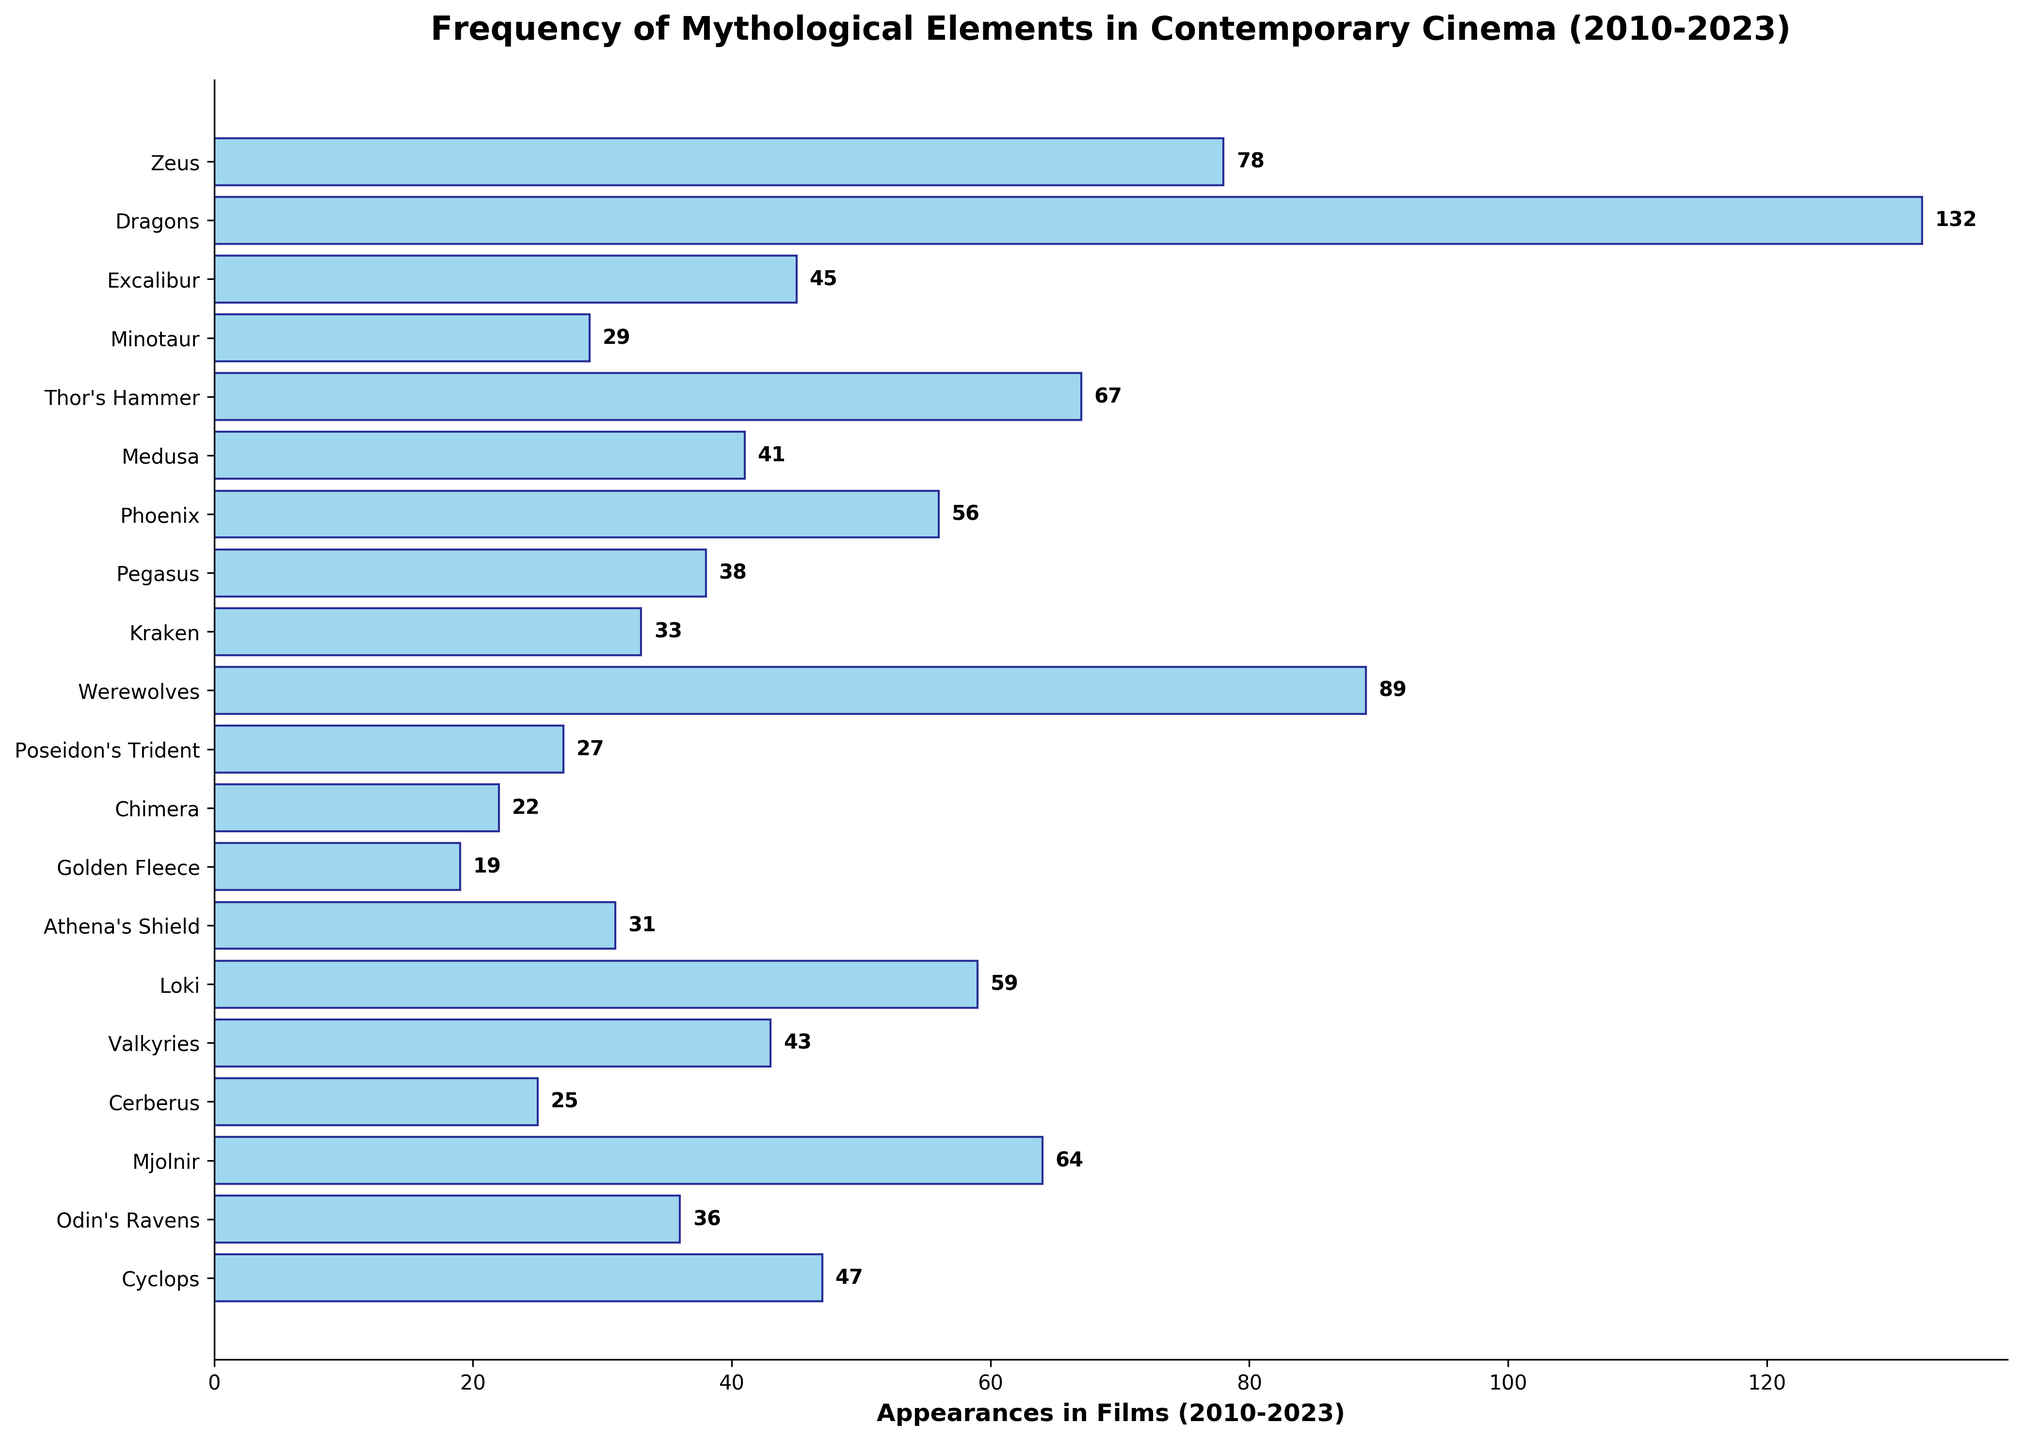What mythological element appears the most frequently in films from 2010 to 2023? To find the most frequent element, look at the bar with the greatest length on the chart. The longest bar represents Dragons with 132 appearances.
Answer: Dragons What is the total number of appearances for Pegasus, Phoenix, and Odin's Ravens together? Sum the appearances of Pegasus (38), Phoenix (56), and Odin's Ravens (36). The total is 38 + 56 + 36 = 130.
Answer: 130 Which mythological element has more appearances: Zeus or Thor's Hammer? Compare the lengths of the bars for Zeus and Thor's Hammer. Zeus has 78 appearances, while Thor's Hammer has 67.
Answer: Zeus What is the difference in appearances between Mjolnir and Loki? Subtract the appearance count of Loki (59) from Mjolnir (64). The difference is 64 - 59 = 5.
Answer: 5 How many mythological elements have appearances less than 30? Count the bars with values less than 30. These are Minotaur (29), Poseidon's Trident (27), Chimera (22), Golden Fleece (19), and Cerberus (25). There are 5 such elements.
Answer: 5 What is the mean number of appearances for the three most frequent mythological elements? The top three elements are Dragons (132), Werewolves (89), and Zeus (78). Sum their appearances and divide by 3. (132 + 89 + 78) / 3 = 299 / 3 = 99.67.
Answer: 99.67 Which element has fewer appearances: Medusa or Cyclops? Compare the lengths of Medusa and Cyclops. Medusa has 41 appearances, while Cyclops has 47.
Answer: Medusa How many elements have appearances between 40 and 60 inclusive? Count the bars where the appearance number is between 40 and 60, including both limits. These elements are Medusa (41), Valkyries (43), and Loki (59). Total is 3.
Answer: 3 What is the average appearance count of elements Zeus, Dragons, and Excalibur? Sum the appearances of Zeus (78), Dragons (132), and Excalibur (45) and divide by 3. (78 + 132 + 45) / 3 = 255 / 3 = 85.
Answer: 85 